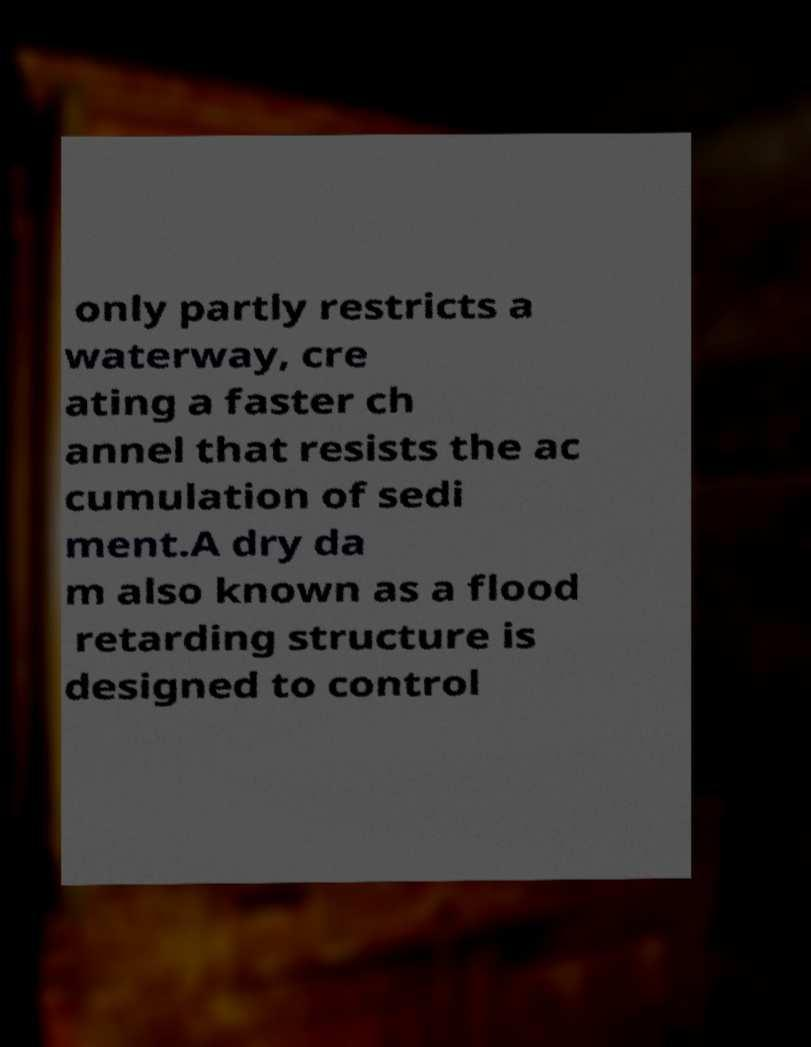Could you extract and type out the text from this image? only partly restricts a waterway, cre ating a faster ch annel that resists the ac cumulation of sedi ment.A dry da m also known as a flood retarding structure is designed to control 